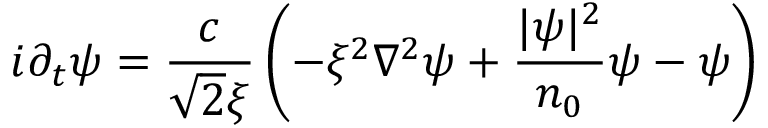Convert formula to latex. <formula><loc_0><loc_0><loc_500><loc_500>i \partial _ { t } \psi = \frac { c } { \sqrt { 2 } \xi } \left ( - \xi ^ { 2 } \nabla ^ { 2 } \psi + \frac { | \psi | ^ { 2 } } { n _ { 0 } } \psi - \psi \right )</formula> 